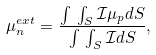<formula> <loc_0><loc_0><loc_500><loc_500>\mu _ { n } ^ { e x t } = \frac { \int \, \int _ { S } \mathcal { I } \mu _ { p } d S } { \int \, \int _ { S } \mathcal { I } d S } ,</formula> 